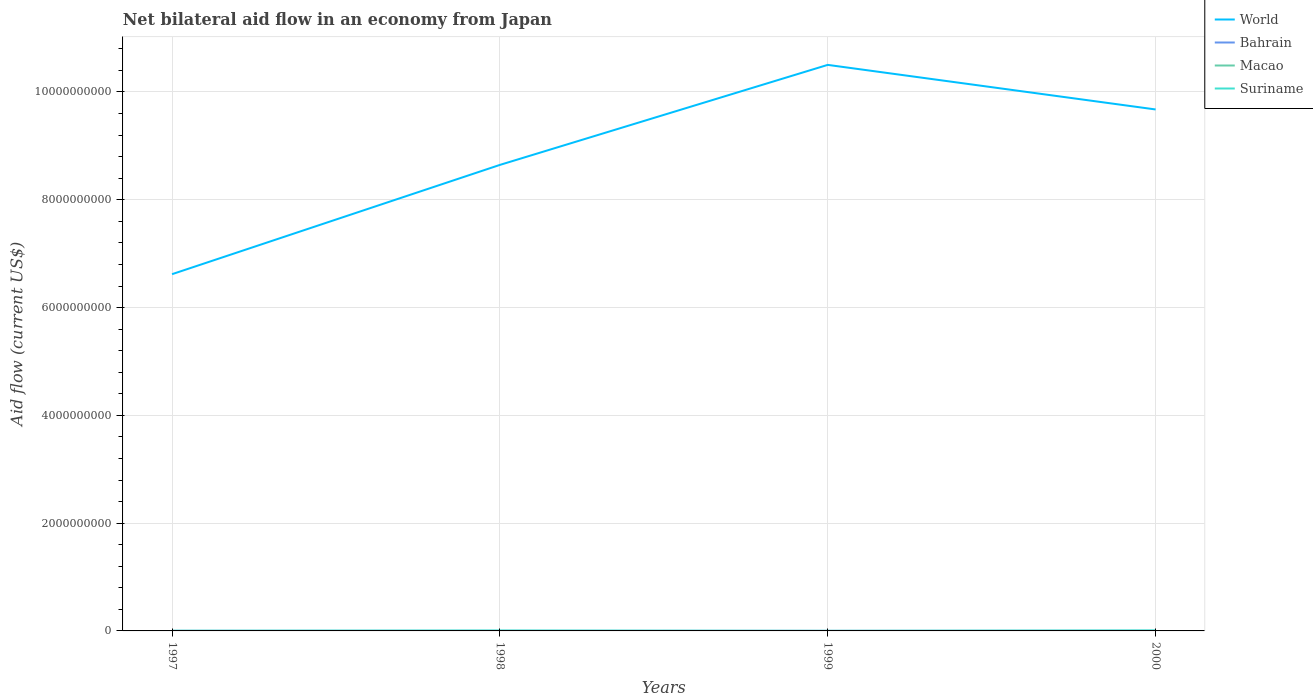How many different coloured lines are there?
Offer a terse response. 4. Across all years, what is the maximum net bilateral aid flow in Macao?
Provide a succinct answer. 1.30e+05. What is the difference between the highest and the second highest net bilateral aid flow in World?
Your answer should be very brief. 3.88e+09. Is the net bilateral aid flow in Suriname strictly greater than the net bilateral aid flow in World over the years?
Offer a terse response. Yes. What is the difference between two consecutive major ticks on the Y-axis?
Offer a terse response. 2.00e+09. Does the graph contain any zero values?
Provide a short and direct response. No. Does the graph contain grids?
Your answer should be very brief. Yes. Where does the legend appear in the graph?
Your answer should be compact. Top right. How many legend labels are there?
Ensure brevity in your answer.  4. What is the title of the graph?
Provide a short and direct response. Net bilateral aid flow in an economy from Japan. Does "Swaziland" appear as one of the legend labels in the graph?
Offer a terse response. No. What is the label or title of the X-axis?
Offer a very short reply. Years. What is the label or title of the Y-axis?
Give a very brief answer. Aid flow (current US$). What is the Aid flow (current US$) of World in 1997?
Give a very brief answer. 6.62e+09. What is the Aid flow (current US$) of Bahrain in 1997?
Offer a very short reply. 1.11e+06. What is the Aid flow (current US$) of Macao in 1997?
Your response must be concise. 1.60e+05. What is the Aid flow (current US$) in Suriname in 1997?
Provide a succinct answer. 2.91e+06. What is the Aid flow (current US$) in World in 1998?
Ensure brevity in your answer.  8.65e+09. What is the Aid flow (current US$) of Bahrain in 1998?
Your response must be concise. 5.90e+05. What is the Aid flow (current US$) in Macao in 1998?
Make the answer very short. 1.30e+05. What is the Aid flow (current US$) in Suriname in 1998?
Offer a terse response. 7.68e+06. What is the Aid flow (current US$) of World in 1999?
Your response must be concise. 1.05e+1. What is the Aid flow (current US$) in Bahrain in 1999?
Offer a very short reply. 1.09e+06. What is the Aid flow (current US$) of Macao in 1999?
Give a very brief answer. 2.10e+05. What is the Aid flow (current US$) of Suriname in 1999?
Keep it short and to the point. 7.60e+05. What is the Aid flow (current US$) in World in 2000?
Offer a very short reply. 9.68e+09. What is the Aid flow (current US$) in Bahrain in 2000?
Make the answer very short. 1.12e+06. What is the Aid flow (current US$) of Macao in 2000?
Keep it short and to the point. 1.50e+05. What is the Aid flow (current US$) in Suriname in 2000?
Your answer should be compact. 9.70e+06. Across all years, what is the maximum Aid flow (current US$) in World?
Provide a short and direct response. 1.05e+1. Across all years, what is the maximum Aid flow (current US$) of Bahrain?
Offer a terse response. 1.12e+06. Across all years, what is the maximum Aid flow (current US$) of Suriname?
Your response must be concise. 9.70e+06. Across all years, what is the minimum Aid flow (current US$) of World?
Your response must be concise. 6.62e+09. Across all years, what is the minimum Aid flow (current US$) of Bahrain?
Offer a terse response. 5.90e+05. Across all years, what is the minimum Aid flow (current US$) in Macao?
Make the answer very short. 1.30e+05. Across all years, what is the minimum Aid flow (current US$) of Suriname?
Your answer should be compact. 7.60e+05. What is the total Aid flow (current US$) of World in the graph?
Give a very brief answer. 3.54e+1. What is the total Aid flow (current US$) of Bahrain in the graph?
Provide a succinct answer. 3.91e+06. What is the total Aid flow (current US$) in Macao in the graph?
Make the answer very short. 6.50e+05. What is the total Aid flow (current US$) in Suriname in the graph?
Keep it short and to the point. 2.10e+07. What is the difference between the Aid flow (current US$) in World in 1997 and that in 1998?
Keep it short and to the point. -2.03e+09. What is the difference between the Aid flow (current US$) of Bahrain in 1997 and that in 1998?
Ensure brevity in your answer.  5.20e+05. What is the difference between the Aid flow (current US$) in Suriname in 1997 and that in 1998?
Your response must be concise. -4.77e+06. What is the difference between the Aid flow (current US$) in World in 1997 and that in 1999?
Make the answer very short. -3.88e+09. What is the difference between the Aid flow (current US$) of Macao in 1997 and that in 1999?
Ensure brevity in your answer.  -5.00e+04. What is the difference between the Aid flow (current US$) in Suriname in 1997 and that in 1999?
Offer a terse response. 2.15e+06. What is the difference between the Aid flow (current US$) in World in 1997 and that in 2000?
Ensure brevity in your answer.  -3.06e+09. What is the difference between the Aid flow (current US$) of Bahrain in 1997 and that in 2000?
Ensure brevity in your answer.  -10000. What is the difference between the Aid flow (current US$) in Macao in 1997 and that in 2000?
Offer a terse response. 10000. What is the difference between the Aid flow (current US$) in Suriname in 1997 and that in 2000?
Keep it short and to the point. -6.79e+06. What is the difference between the Aid flow (current US$) in World in 1998 and that in 1999?
Provide a short and direct response. -1.86e+09. What is the difference between the Aid flow (current US$) of Bahrain in 1998 and that in 1999?
Your response must be concise. -5.00e+05. What is the difference between the Aid flow (current US$) in Macao in 1998 and that in 1999?
Give a very brief answer. -8.00e+04. What is the difference between the Aid flow (current US$) in Suriname in 1998 and that in 1999?
Ensure brevity in your answer.  6.92e+06. What is the difference between the Aid flow (current US$) in World in 1998 and that in 2000?
Provide a short and direct response. -1.03e+09. What is the difference between the Aid flow (current US$) in Bahrain in 1998 and that in 2000?
Make the answer very short. -5.30e+05. What is the difference between the Aid flow (current US$) of Suriname in 1998 and that in 2000?
Give a very brief answer. -2.02e+06. What is the difference between the Aid flow (current US$) in World in 1999 and that in 2000?
Provide a short and direct response. 8.27e+08. What is the difference between the Aid flow (current US$) in Suriname in 1999 and that in 2000?
Provide a succinct answer. -8.94e+06. What is the difference between the Aid flow (current US$) of World in 1997 and the Aid flow (current US$) of Bahrain in 1998?
Provide a succinct answer. 6.62e+09. What is the difference between the Aid flow (current US$) in World in 1997 and the Aid flow (current US$) in Macao in 1998?
Provide a succinct answer. 6.62e+09. What is the difference between the Aid flow (current US$) in World in 1997 and the Aid flow (current US$) in Suriname in 1998?
Offer a very short reply. 6.61e+09. What is the difference between the Aid flow (current US$) of Bahrain in 1997 and the Aid flow (current US$) of Macao in 1998?
Your answer should be very brief. 9.80e+05. What is the difference between the Aid flow (current US$) of Bahrain in 1997 and the Aid flow (current US$) of Suriname in 1998?
Provide a succinct answer. -6.57e+06. What is the difference between the Aid flow (current US$) of Macao in 1997 and the Aid flow (current US$) of Suriname in 1998?
Provide a short and direct response. -7.52e+06. What is the difference between the Aid flow (current US$) in World in 1997 and the Aid flow (current US$) in Bahrain in 1999?
Your answer should be very brief. 6.62e+09. What is the difference between the Aid flow (current US$) of World in 1997 and the Aid flow (current US$) of Macao in 1999?
Give a very brief answer. 6.62e+09. What is the difference between the Aid flow (current US$) in World in 1997 and the Aid flow (current US$) in Suriname in 1999?
Your answer should be very brief. 6.62e+09. What is the difference between the Aid flow (current US$) in Bahrain in 1997 and the Aid flow (current US$) in Suriname in 1999?
Provide a short and direct response. 3.50e+05. What is the difference between the Aid flow (current US$) in Macao in 1997 and the Aid flow (current US$) in Suriname in 1999?
Offer a terse response. -6.00e+05. What is the difference between the Aid flow (current US$) in World in 1997 and the Aid flow (current US$) in Bahrain in 2000?
Your answer should be very brief. 6.62e+09. What is the difference between the Aid flow (current US$) of World in 1997 and the Aid flow (current US$) of Macao in 2000?
Make the answer very short. 6.62e+09. What is the difference between the Aid flow (current US$) of World in 1997 and the Aid flow (current US$) of Suriname in 2000?
Keep it short and to the point. 6.61e+09. What is the difference between the Aid flow (current US$) of Bahrain in 1997 and the Aid flow (current US$) of Macao in 2000?
Your response must be concise. 9.60e+05. What is the difference between the Aid flow (current US$) in Bahrain in 1997 and the Aid flow (current US$) in Suriname in 2000?
Offer a very short reply. -8.59e+06. What is the difference between the Aid flow (current US$) of Macao in 1997 and the Aid flow (current US$) of Suriname in 2000?
Ensure brevity in your answer.  -9.54e+06. What is the difference between the Aid flow (current US$) in World in 1998 and the Aid flow (current US$) in Bahrain in 1999?
Your answer should be very brief. 8.65e+09. What is the difference between the Aid flow (current US$) of World in 1998 and the Aid flow (current US$) of Macao in 1999?
Ensure brevity in your answer.  8.65e+09. What is the difference between the Aid flow (current US$) of World in 1998 and the Aid flow (current US$) of Suriname in 1999?
Keep it short and to the point. 8.65e+09. What is the difference between the Aid flow (current US$) in Macao in 1998 and the Aid flow (current US$) in Suriname in 1999?
Offer a very short reply. -6.30e+05. What is the difference between the Aid flow (current US$) of World in 1998 and the Aid flow (current US$) of Bahrain in 2000?
Your answer should be compact. 8.65e+09. What is the difference between the Aid flow (current US$) in World in 1998 and the Aid flow (current US$) in Macao in 2000?
Provide a short and direct response. 8.65e+09. What is the difference between the Aid flow (current US$) in World in 1998 and the Aid flow (current US$) in Suriname in 2000?
Make the answer very short. 8.64e+09. What is the difference between the Aid flow (current US$) of Bahrain in 1998 and the Aid flow (current US$) of Macao in 2000?
Offer a very short reply. 4.40e+05. What is the difference between the Aid flow (current US$) of Bahrain in 1998 and the Aid flow (current US$) of Suriname in 2000?
Make the answer very short. -9.11e+06. What is the difference between the Aid flow (current US$) in Macao in 1998 and the Aid flow (current US$) in Suriname in 2000?
Provide a succinct answer. -9.57e+06. What is the difference between the Aid flow (current US$) in World in 1999 and the Aid flow (current US$) in Bahrain in 2000?
Offer a very short reply. 1.05e+1. What is the difference between the Aid flow (current US$) of World in 1999 and the Aid flow (current US$) of Macao in 2000?
Give a very brief answer. 1.05e+1. What is the difference between the Aid flow (current US$) of World in 1999 and the Aid flow (current US$) of Suriname in 2000?
Provide a succinct answer. 1.05e+1. What is the difference between the Aid flow (current US$) of Bahrain in 1999 and the Aid flow (current US$) of Macao in 2000?
Provide a succinct answer. 9.40e+05. What is the difference between the Aid flow (current US$) in Bahrain in 1999 and the Aid flow (current US$) in Suriname in 2000?
Your response must be concise. -8.61e+06. What is the difference between the Aid flow (current US$) of Macao in 1999 and the Aid flow (current US$) of Suriname in 2000?
Ensure brevity in your answer.  -9.49e+06. What is the average Aid flow (current US$) in World per year?
Offer a terse response. 8.86e+09. What is the average Aid flow (current US$) in Bahrain per year?
Provide a short and direct response. 9.78e+05. What is the average Aid flow (current US$) in Macao per year?
Ensure brevity in your answer.  1.62e+05. What is the average Aid flow (current US$) of Suriname per year?
Make the answer very short. 5.26e+06. In the year 1997, what is the difference between the Aid flow (current US$) of World and Aid flow (current US$) of Bahrain?
Your answer should be compact. 6.62e+09. In the year 1997, what is the difference between the Aid flow (current US$) of World and Aid flow (current US$) of Macao?
Ensure brevity in your answer.  6.62e+09. In the year 1997, what is the difference between the Aid flow (current US$) in World and Aid flow (current US$) in Suriname?
Ensure brevity in your answer.  6.62e+09. In the year 1997, what is the difference between the Aid flow (current US$) of Bahrain and Aid flow (current US$) of Macao?
Keep it short and to the point. 9.50e+05. In the year 1997, what is the difference between the Aid flow (current US$) in Bahrain and Aid flow (current US$) in Suriname?
Your response must be concise. -1.80e+06. In the year 1997, what is the difference between the Aid flow (current US$) of Macao and Aid flow (current US$) of Suriname?
Make the answer very short. -2.75e+06. In the year 1998, what is the difference between the Aid flow (current US$) of World and Aid flow (current US$) of Bahrain?
Provide a succinct answer. 8.65e+09. In the year 1998, what is the difference between the Aid flow (current US$) of World and Aid flow (current US$) of Macao?
Your answer should be compact. 8.65e+09. In the year 1998, what is the difference between the Aid flow (current US$) in World and Aid flow (current US$) in Suriname?
Your answer should be very brief. 8.64e+09. In the year 1998, what is the difference between the Aid flow (current US$) of Bahrain and Aid flow (current US$) of Suriname?
Ensure brevity in your answer.  -7.09e+06. In the year 1998, what is the difference between the Aid flow (current US$) in Macao and Aid flow (current US$) in Suriname?
Offer a terse response. -7.55e+06. In the year 1999, what is the difference between the Aid flow (current US$) of World and Aid flow (current US$) of Bahrain?
Your answer should be compact. 1.05e+1. In the year 1999, what is the difference between the Aid flow (current US$) in World and Aid flow (current US$) in Macao?
Keep it short and to the point. 1.05e+1. In the year 1999, what is the difference between the Aid flow (current US$) of World and Aid flow (current US$) of Suriname?
Give a very brief answer. 1.05e+1. In the year 1999, what is the difference between the Aid flow (current US$) in Bahrain and Aid flow (current US$) in Macao?
Keep it short and to the point. 8.80e+05. In the year 1999, what is the difference between the Aid flow (current US$) in Macao and Aid flow (current US$) in Suriname?
Ensure brevity in your answer.  -5.50e+05. In the year 2000, what is the difference between the Aid flow (current US$) in World and Aid flow (current US$) in Bahrain?
Your response must be concise. 9.67e+09. In the year 2000, what is the difference between the Aid flow (current US$) in World and Aid flow (current US$) in Macao?
Give a very brief answer. 9.68e+09. In the year 2000, what is the difference between the Aid flow (current US$) of World and Aid flow (current US$) of Suriname?
Offer a very short reply. 9.67e+09. In the year 2000, what is the difference between the Aid flow (current US$) of Bahrain and Aid flow (current US$) of Macao?
Keep it short and to the point. 9.70e+05. In the year 2000, what is the difference between the Aid flow (current US$) of Bahrain and Aid flow (current US$) of Suriname?
Make the answer very short. -8.58e+06. In the year 2000, what is the difference between the Aid flow (current US$) of Macao and Aid flow (current US$) of Suriname?
Offer a very short reply. -9.55e+06. What is the ratio of the Aid flow (current US$) in World in 1997 to that in 1998?
Offer a very short reply. 0.77. What is the ratio of the Aid flow (current US$) of Bahrain in 1997 to that in 1998?
Ensure brevity in your answer.  1.88. What is the ratio of the Aid flow (current US$) of Macao in 1997 to that in 1998?
Your answer should be very brief. 1.23. What is the ratio of the Aid flow (current US$) in Suriname in 1997 to that in 1998?
Your answer should be very brief. 0.38. What is the ratio of the Aid flow (current US$) of World in 1997 to that in 1999?
Your response must be concise. 0.63. What is the ratio of the Aid flow (current US$) in Bahrain in 1997 to that in 1999?
Offer a very short reply. 1.02. What is the ratio of the Aid flow (current US$) of Macao in 1997 to that in 1999?
Give a very brief answer. 0.76. What is the ratio of the Aid flow (current US$) in Suriname in 1997 to that in 1999?
Make the answer very short. 3.83. What is the ratio of the Aid flow (current US$) of World in 1997 to that in 2000?
Make the answer very short. 0.68. What is the ratio of the Aid flow (current US$) in Bahrain in 1997 to that in 2000?
Make the answer very short. 0.99. What is the ratio of the Aid flow (current US$) in Macao in 1997 to that in 2000?
Provide a short and direct response. 1.07. What is the ratio of the Aid flow (current US$) in Suriname in 1997 to that in 2000?
Keep it short and to the point. 0.3. What is the ratio of the Aid flow (current US$) in World in 1998 to that in 1999?
Provide a succinct answer. 0.82. What is the ratio of the Aid flow (current US$) in Bahrain in 1998 to that in 1999?
Provide a succinct answer. 0.54. What is the ratio of the Aid flow (current US$) in Macao in 1998 to that in 1999?
Provide a short and direct response. 0.62. What is the ratio of the Aid flow (current US$) of Suriname in 1998 to that in 1999?
Provide a short and direct response. 10.11. What is the ratio of the Aid flow (current US$) in World in 1998 to that in 2000?
Offer a very short reply. 0.89. What is the ratio of the Aid flow (current US$) in Bahrain in 1998 to that in 2000?
Give a very brief answer. 0.53. What is the ratio of the Aid flow (current US$) in Macao in 1998 to that in 2000?
Your answer should be very brief. 0.87. What is the ratio of the Aid flow (current US$) in Suriname in 1998 to that in 2000?
Make the answer very short. 0.79. What is the ratio of the Aid flow (current US$) of World in 1999 to that in 2000?
Your answer should be very brief. 1.09. What is the ratio of the Aid flow (current US$) in Bahrain in 1999 to that in 2000?
Give a very brief answer. 0.97. What is the ratio of the Aid flow (current US$) in Macao in 1999 to that in 2000?
Keep it short and to the point. 1.4. What is the ratio of the Aid flow (current US$) of Suriname in 1999 to that in 2000?
Provide a succinct answer. 0.08. What is the difference between the highest and the second highest Aid flow (current US$) of World?
Your answer should be compact. 8.27e+08. What is the difference between the highest and the second highest Aid flow (current US$) of Bahrain?
Your response must be concise. 10000. What is the difference between the highest and the second highest Aid flow (current US$) in Macao?
Your answer should be compact. 5.00e+04. What is the difference between the highest and the second highest Aid flow (current US$) of Suriname?
Make the answer very short. 2.02e+06. What is the difference between the highest and the lowest Aid flow (current US$) in World?
Make the answer very short. 3.88e+09. What is the difference between the highest and the lowest Aid flow (current US$) in Bahrain?
Give a very brief answer. 5.30e+05. What is the difference between the highest and the lowest Aid flow (current US$) of Suriname?
Give a very brief answer. 8.94e+06. 